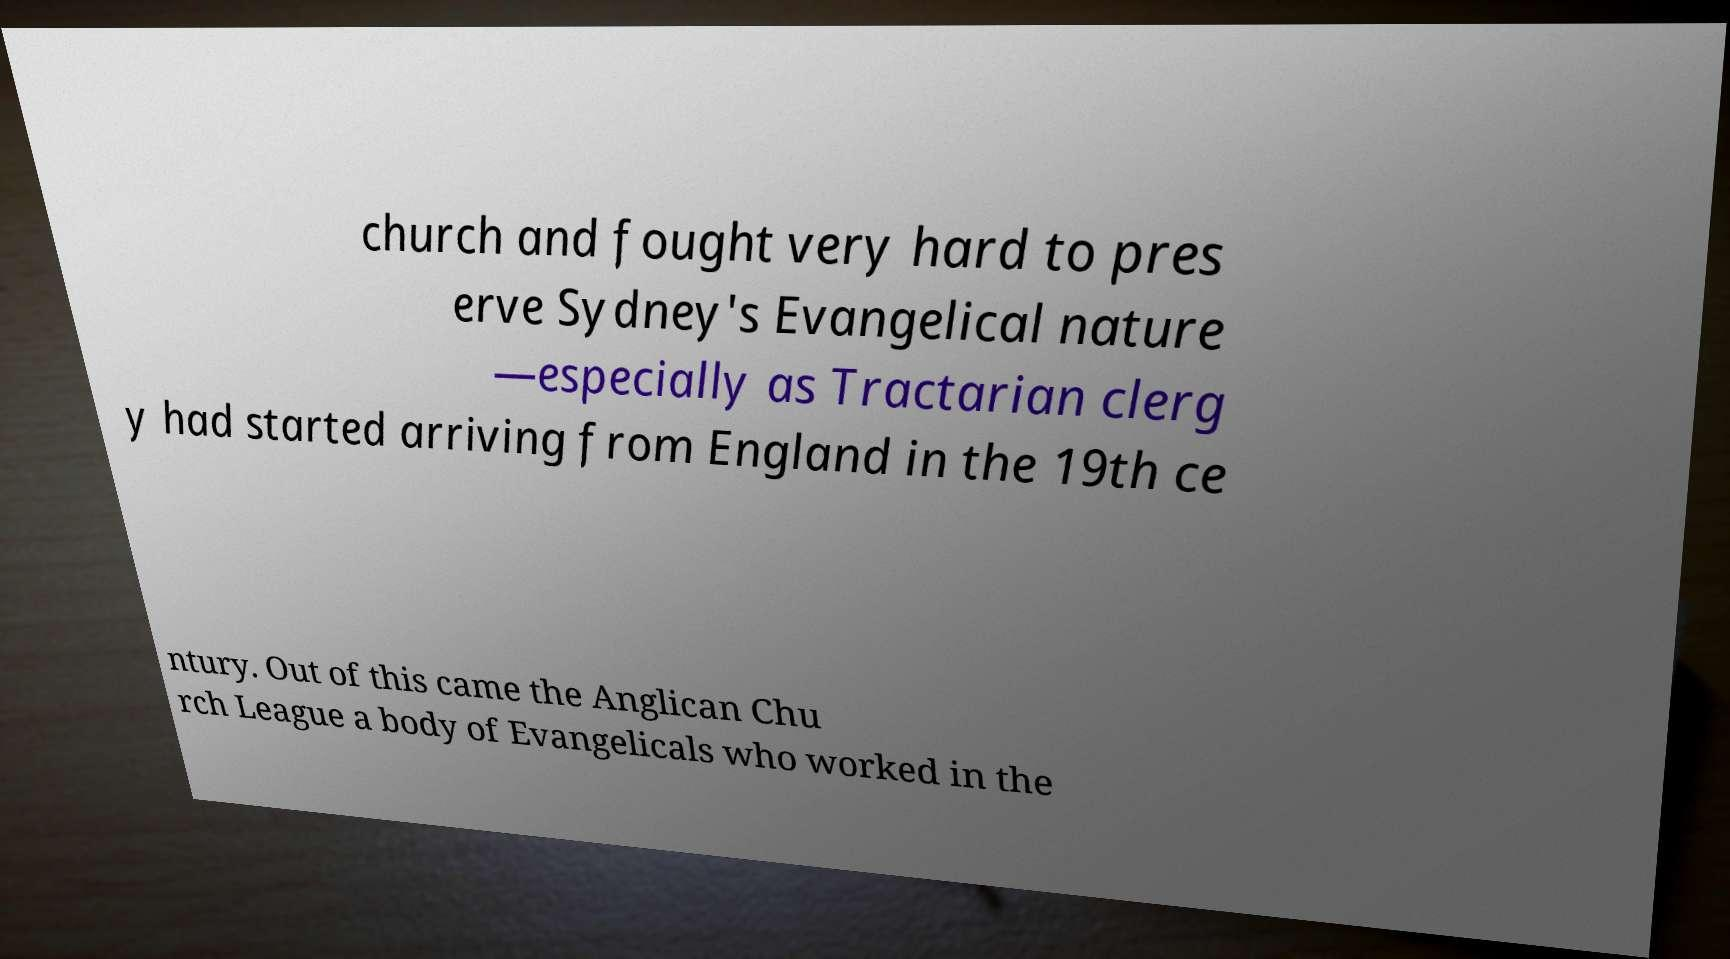Can you read and provide the text displayed in the image?This photo seems to have some interesting text. Can you extract and type it out for me? church and fought very hard to pres erve Sydney's Evangelical nature —especially as Tractarian clerg y had started arriving from England in the 19th ce ntury. Out of this came the Anglican Chu rch League a body of Evangelicals who worked in the 